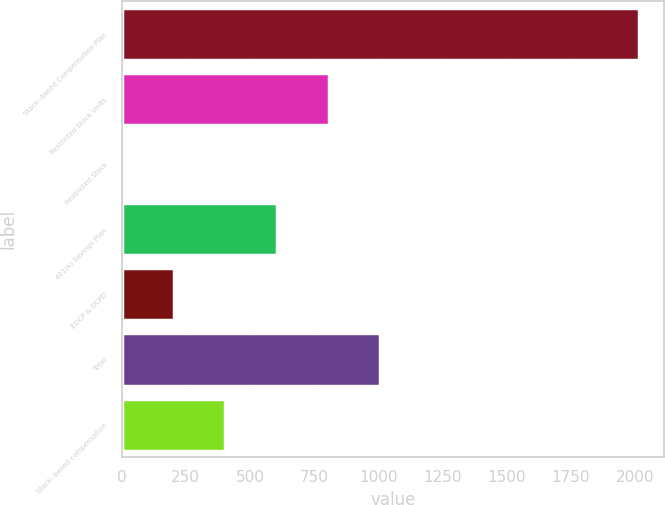Convert chart. <chart><loc_0><loc_0><loc_500><loc_500><bar_chart><fcel>Stock-­based Compensation Plan<fcel>Restricted Stock Units<fcel>Restricted Stock<fcel>401(k) Savings Plan<fcel>EDCP & DCPD<fcel>Total<fcel>Stock-­based compensation<nl><fcel>2015<fcel>807.2<fcel>2<fcel>605.9<fcel>203.3<fcel>1008.5<fcel>404.6<nl></chart> 